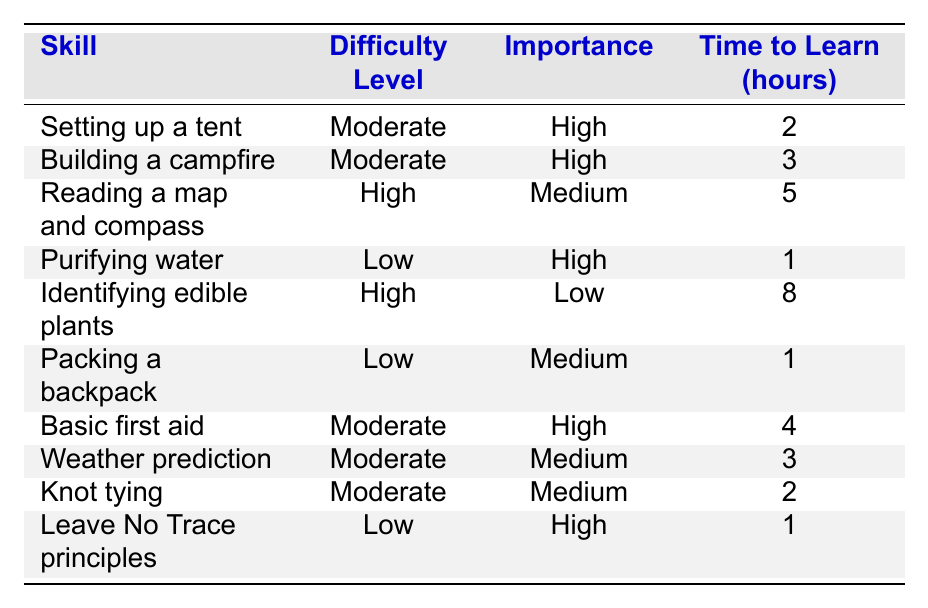What skill takes the least time to learn? By looking at the table, "Purifying water," "Packing a backpack," and "Leave No Trace principles" all take 1 hour to learn. Therefore, any of these skills can be considered as taking the least time.
Answer: Purifying water, Packing a backpack, Leave No Trace principles Which skill has the highest difficulty level? The skills "Reading a map and compass" and "Identifying edible plants" both have a difficulty level rated as High, which is the highest category listed in the table.
Answer: Reading a map and compass, Identifying edible plants How many skills have a moderate difficulty level? By reviewing the table, we can see that there are 4 skills (Setting up a tent, Building a campfire, Basic first aid, Weather prediction, Knot tying) rated as Moderate difficulty.
Answer: 5 Is identifying edible plants considered a high-importance skill? No, the table shows that the skill "Identifying edible plants" has a Low importance rating, indicating it is not considered high-importance.
Answer: No What is the total time required to learn all the skills with high importance? The skills with high importance are "Setting up a tent" (2), "Building a campfire" (3), "Purifying water" (1), "Basic first aid" (4), and "Leave No Trace principles" (1), which sum up to 2 + 3 + 1 + 4 + 1 = 11 hours.
Answer: 11 What percentage of the skills listed are considered low difficulty? There are 3 skills (Purifying water, Packing a backpack, Leave No Trace principles) classified as Low difficulty out of a total of 10 skills. To find the percentage, calculate (3/10) * 100 = 30%.
Answer: 30% If I want to learn a skill that is both high importance and low difficulty, which skill should I choose? According to the table, "Purifying water" and "Leave No Trace principles" are the only skills that have both High importance and Low difficulty.
Answer: Purifying water, Leave No Trace principles What is the average time to learn a skill rated as Moderate difficulty? The skills with a Moderate difficulty level and their times are: "Setting up a tent" (2), "Building a campfire" (3), "Basic first aid" (4), "Weather prediction" (3), "Knot tying" (2). Adding these up gives 2 + 3 + 4 + 3 + 2 = 14 hours. Dividing by the number of skills (5), the average time is 14 / 5 = 2.8 hours.
Answer: 2.8 Which skill with low difficulty takes the most time to learn? Among the skills with a Low difficulty rating, "Packing a backpack" and "Leave No Trace principles" take 1 hour each, while "Purifying water" also takes 1 hour. Thus, there is no skill with a low difficulty rating that takes more time.
Answer: None 